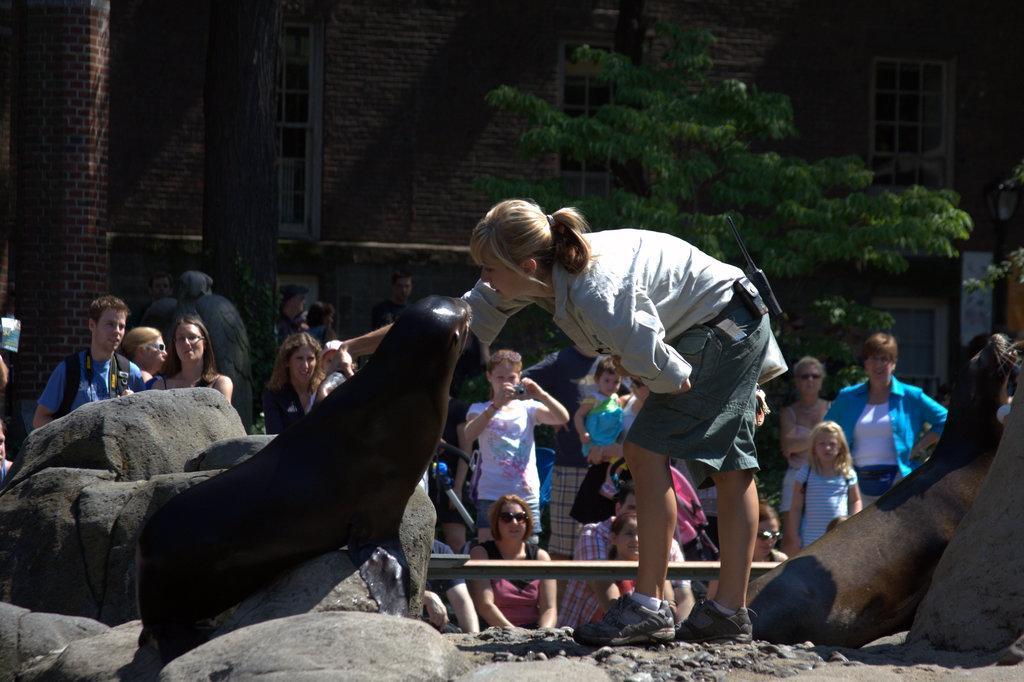In one or two sentences, can you explain what this image depicts? Here on the left there is a dolphin and next to it there is a woman in squat position. In the background there are few people standing and sitting and we can also see stones,building,windows,trees and on the right there is a dolphin on the ground. 